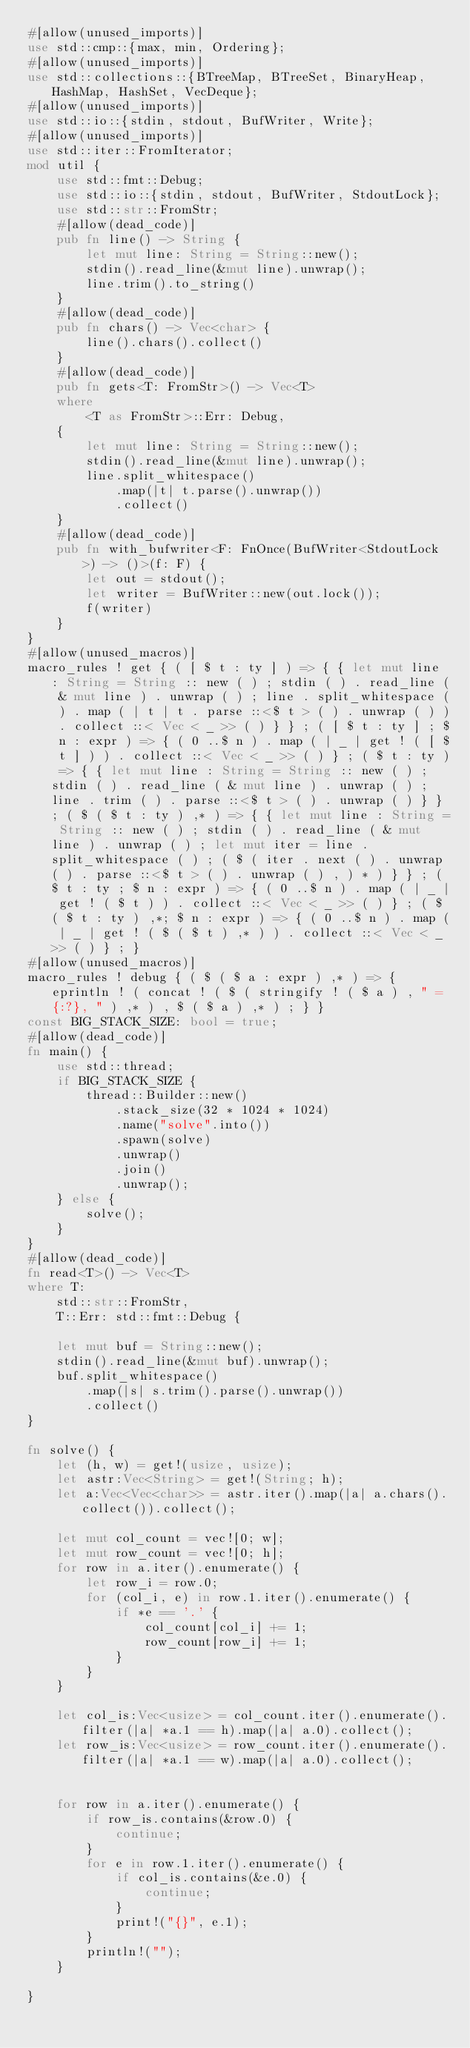Convert code to text. <code><loc_0><loc_0><loc_500><loc_500><_Rust_>#[allow(unused_imports)]
use std::cmp::{max, min, Ordering};
#[allow(unused_imports)]
use std::collections::{BTreeMap, BTreeSet, BinaryHeap, HashMap, HashSet, VecDeque};
#[allow(unused_imports)]
use std::io::{stdin, stdout, BufWriter, Write};
#[allow(unused_imports)]
use std::iter::FromIterator;
mod util {
    use std::fmt::Debug;
    use std::io::{stdin, stdout, BufWriter, StdoutLock};
    use std::str::FromStr;
    #[allow(dead_code)]
    pub fn line() -> String {
        let mut line: String = String::new();
        stdin().read_line(&mut line).unwrap();
        line.trim().to_string()
    }
    #[allow(dead_code)]
    pub fn chars() -> Vec<char> {
        line().chars().collect()
    }
    #[allow(dead_code)]
    pub fn gets<T: FromStr>() -> Vec<T>
    where
        <T as FromStr>::Err: Debug,
    {
        let mut line: String = String::new();
        stdin().read_line(&mut line).unwrap();
        line.split_whitespace()
            .map(|t| t.parse().unwrap())
            .collect()
    }
    #[allow(dead_code)]
    pub fn with_bufwriter<F: FnOnce(BufWriter<StdoutLock>) -> ()>(f: F) {
        let out = stdout();
        let writer = BufWriter::new(out.lock());
        f(writer)
    }
}
#[allow(unused_macros)]
macro_rules ! get { ( [ $ t : ty ] ) => { { let mut line : String = String :: new ( ) ; stdin ( ) . read_line ( & mut line ) . unwrap ( ) ; line . split_whitespace ( ) . map ( | t | t . parse ::<$ t > ( ) . unwrap ( ) ) . collect ::< Vec < _ >> ( ) } } ; ( [ $ t : ty ] ; $ n : expr ) => { ( 0 ..$ n ) . map ( | _ | get ! ( [ $ t ] ) ) . collect ::< Vec < _ >> ( ) } ; ( $ t : ty ) => { { let mut line : String = String :: new ( ) ; stdin ( ) . read_line ( & mut line ) . unwrap ( ) ; line . trim ( ) . parse ::<$ t > ( ) . unwrap ( ) } } ; ( $ ( $ t : ty ) ,* ) => { { let mut line : String = String :: new ( ) ; stdin ( ) . read_line ( & mut line ) . unwrap ( ) ; let mut iter = line . split_whitespace ( ) ; ( $ ( iter . next ( ) . unwrap ( ) . parse ::<$ t > ( ) . unwrap ( ) , ) * ) } } ; ( $ t : ty ; $ n : expr ) => { ( 0 ..$ n ) . map ( | _ | get ! ( $ t ) ) . collect ::< Vec < _ >> ( ) } ; ( $ ( $ t : ty ) ,*; $ n : expr ) => { ( 0 ..$ n ) . map ( | _ | get ! ( $ ( $ t ) ,* ) ) . collect ::< Vec < _ >> ( ) } ; }
#[allow(unused_macros)]
macro_rules ! debug { ( $ ( $ a : expr ) ,* ) => { eprintln ! ( concat ! ( $ ( stringify ! ( $ a ) , " = {:?}, " ) ,* ) , $ ( $ a ) ,* ) ; } }
const BIG_STACK_SIZE: bool = true;
#[allow(dead_code)]
fn main() {
    use std::thread;
    if BIG_STACK_SIZE {
        thread::Builder::new()
            .stack_size(32 * 1024 * 1024)
            .name("solve".into())
            .spawn(solve)
            .unwrap()
            .join()
            .unwrap();
    } else {
        solve();
    }
}
#[allow(dead_code)]
fn read<T>() -> Vec<T>
where T:
    std::str::FromStr,
    T::Err: std::fmt::Debug {

    let mut buf = String::new();
    stdin().read_line(&mut buf).unwrap();
    buf.split_whitespace()
        .map(|s| s.trim().parse().unwrap())
        .collect()
}

fn solve() {
    let (h, w) = get!(usize, usize);
    let astr:Vec<String> = get!(String; h);
    let a:Vec<Vec<char>> = astr.iter().map(|a| a.chars().collect()).collect();

    let mut col_count = vec![0; w];
    let mut row_count = vec![0; h];
    for row in a.iter().enumerate() {
        let row_i = row.0;
        for (col_i, e) in row.1.iter().enumerate() {
            if *e == '.' {
                col_count[col_i] += 1;
                row_count[row_i] += 1;
            }
        }
    }

    let col_is:Vec<usize> = col_count.iter().enumerate().filter(|a| *a.1 == h).map(|a| a.0).collect();
    let row_is:Vec<usize> = row_count.iter().enumerate().filter(|a| *a.1 == w).map(|a| a.0).collect();


    for row in a.iter().enumerate() {
        if row_is.contains(&row.0) {
            continue;
        }
        for e in row.1.iter().enumerate() {
            if col_is.contains(&e.0) {
                continue;
            }
            print!("{}", e.1);
        }
        println!("");
    }

}
</code> 